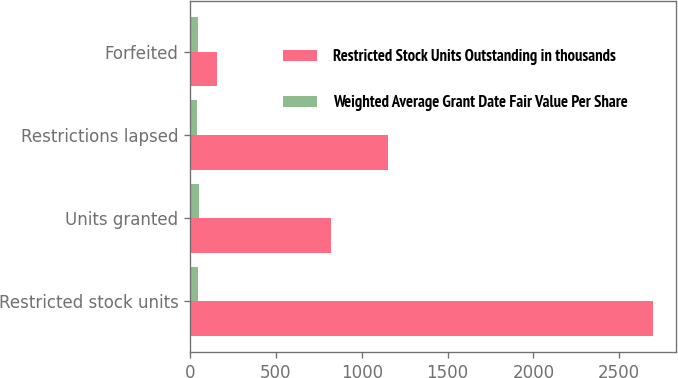Convert chart. <chart><loc_0><loc_0><loc_500><loc_500><stacked_bar_chart><ecel><fcel>Restricted stock units<fcel>Units granted<fcel>Restrictions lapsed<fcel>Forfeited<nl><fcel>Restricted Stock Units Outstanding in thousands<fcel>2698<fcel>818<fcel>1151<fcel>157<nl><fcel>Weighted Average Grant Date Fair Value Per Share<fcel>47.59<fcel>52.25<fcel>39.72<fcel>45.8<nl></chart> 